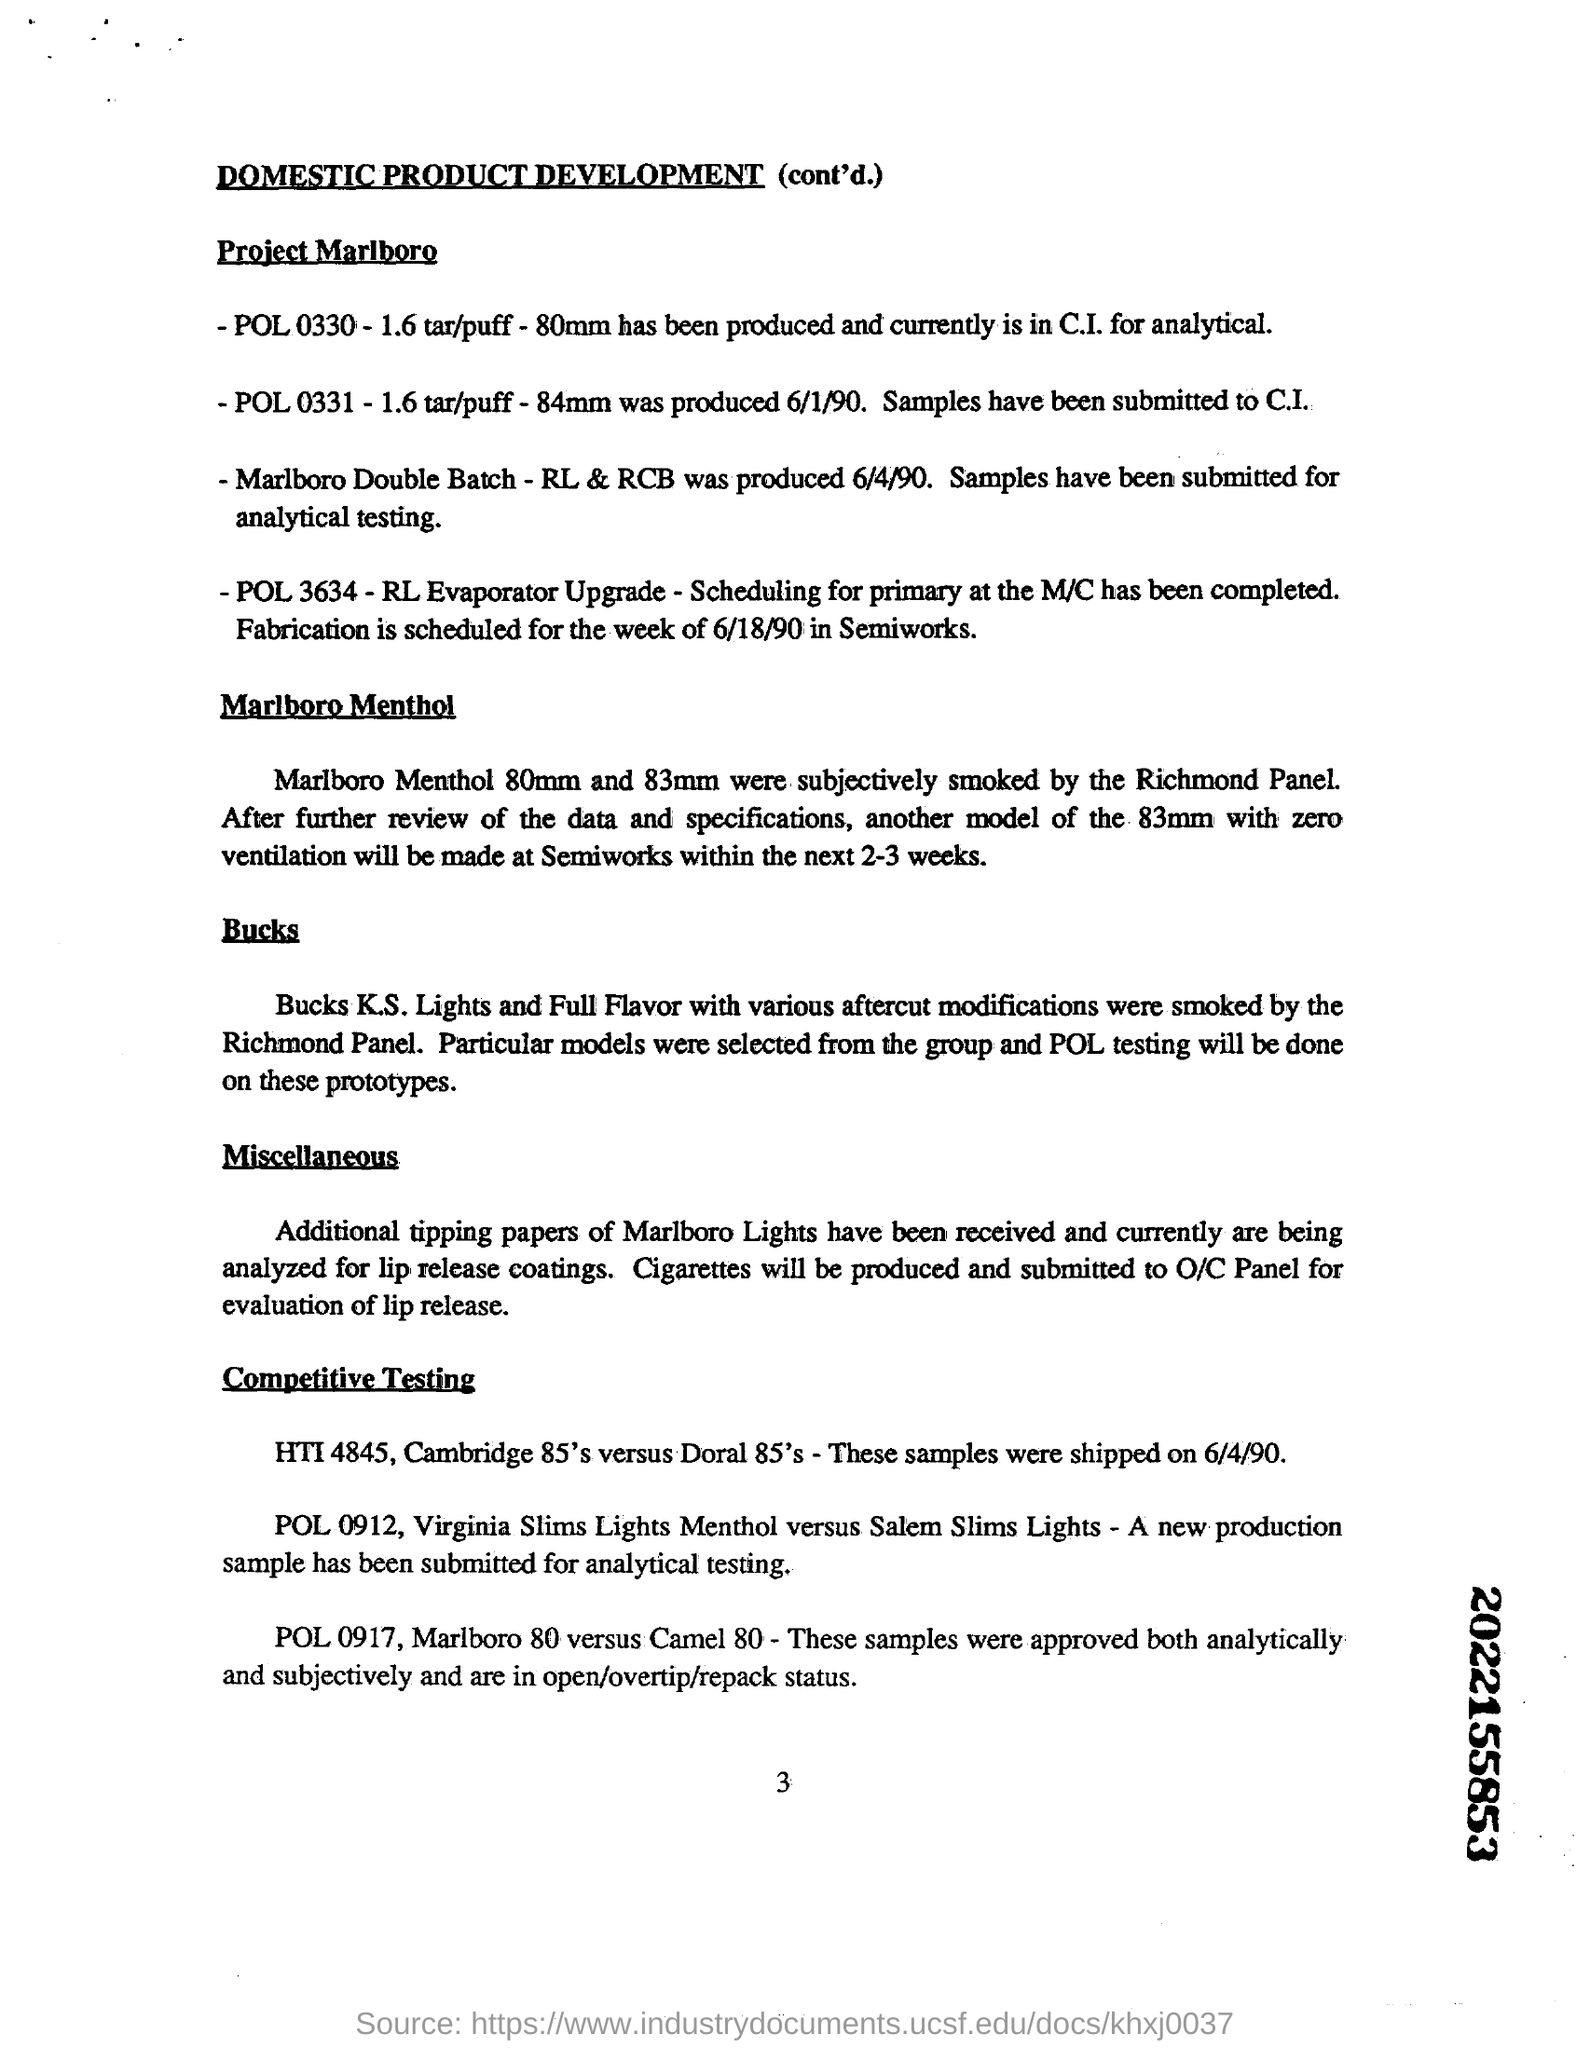What were the outcomes from testing the different sizes? While the document doesn't provide specific results, typically such tests would measure parameters like draw resistance, taste intensity, and consumer satisfaction. The outcome would inform decisions on product adjustments and possible development of new versions tailored to consumer preferences. 